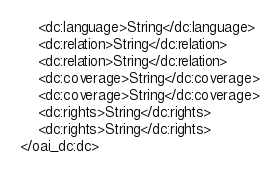Convert code to text. <code><loc_0><loc_0><loc_500><loc_500><_XML_>	<dc:language>String</dc:language>
	<dc:relation>String</dc:relation>
	<dc:relation>String</dc:relation>
	<dc:coverage>String</dc:coverage>
	<dc:coverage>String</dc:coverage>
	<dc:rights>String</dc:rights>
	<dc:rights>String</dc:rights>
</oai_dc:dc>
</code> 